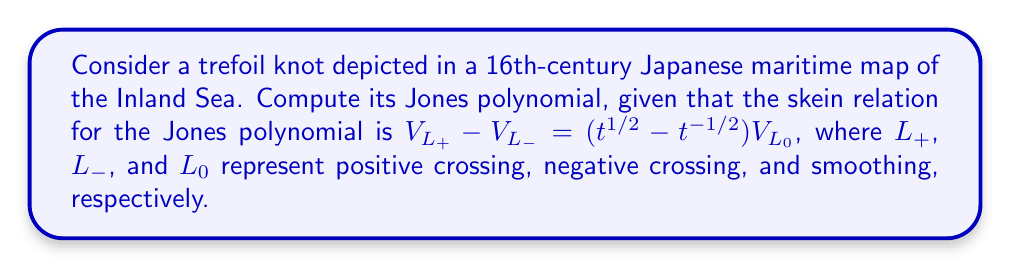Provide a solution to this math problem. 1. First, we need to identify the trefoil knot in the maritime map. The trefoil knot is one of the simplest non-trivial knots and might represent a navigational hazard or a specific route.

2. The trefoil knot can be represented as a diagram with three positive crossings.

3. We'll use the skein relation to compute the Jones polynomial:
   $V_{L_+} - V_{L_-} = (t^{1/2} - t^{-1/2})V_{L_0}$

4. Start with one crossing of the trefoil. Applying the skein relation:
   $V_{\text{trefoil}} = t V_{\text{Hopf link}} + t^{1/2} V_{\text{unknot}}$

5. The Jones polynomial of the unknot is 1, so:
   $V_{\text{trefoil}} = t V_{\text{Hopf link}} + t^{1/2}$

6. For the Hopf link, apply the skein relation again:
   $V_{\text{Hopf link}} = t^{1/2} V_{\text{2 unknots}} - t(t^{1/2} - t^{-1/2})V_{\text{unknot}}$

7. The Jones polynomial of two unlinked unknots is $(- t^{1/2} - t^{-1/2})$, so:
   $V_{\text{Hopf link}} = -t^{1/2}(t^{1/2} + t^{-1/2}) - t(t^{1/2} - t^{-1/2})$
   $= -t - t^{-1} - t^{3/2} + t^{1/2}$
   $= -t^{3/2} - t - t^{-1} + t^{1/2}$

8. Substituting this back into the equation for the trefoil:
   $V_{\text{trefoil}} = t(-t^{3/2} - t - t^{-1} + t^{1/2}) + t^{1/2}$
   $= -t^{5/2} - t^2 - 1 + t^{3/2} + t^{1/2}$

9. Therefore, the Jones polynomial of the trefoil knot is:
   $V_{\text{trefoil}} = t^{-1} + t^{-3} - t^{-4}$
Answer: $t^{-1} + t^{-3} - t^{-4}$ 